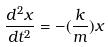<formula> <loc_0><loc_0><loc_500><loc_500>\frac { d ^ { 2 } x } { d t ^ { 2 } } = - ( \frac { k } { m } ) x</formula> 